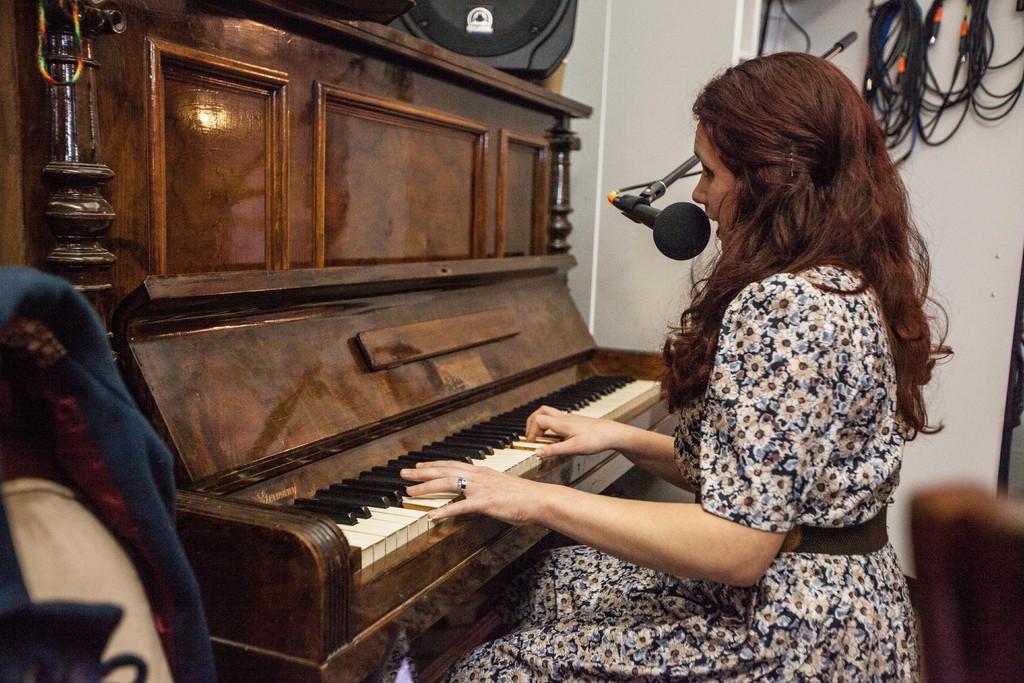How would you summarize this image in a sentence or two? In a room there is a woman sitting and playing piano and behind her there is wall and wires hanging on that. On the other side there is a cloth hanging on the chairs. 